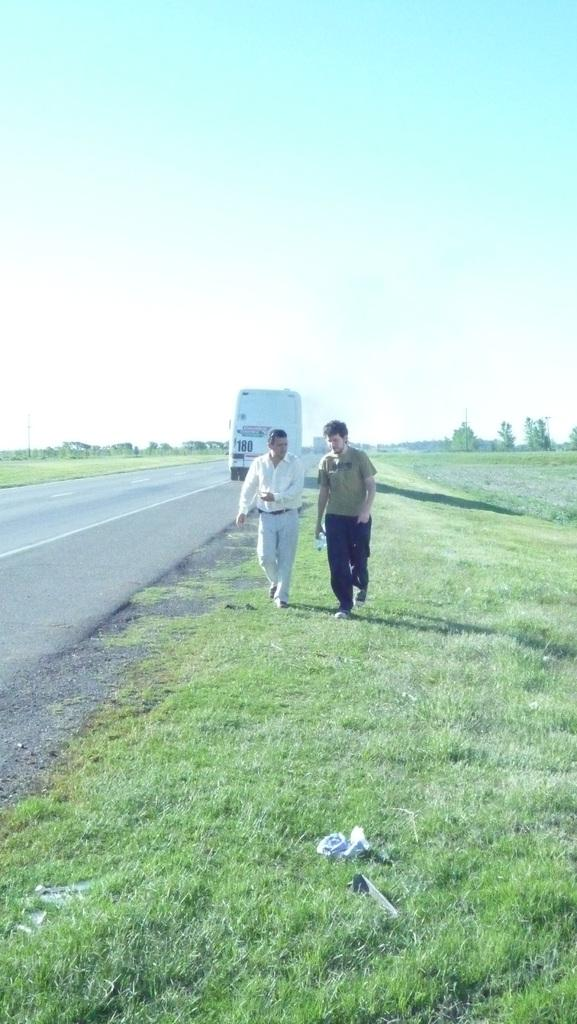What are the persons in the image doing? The persons in the image are walking on the grass in the center of the image. What can be seen in the background of the image? In the background, there is a road, vehicles, grass, trees, and the sky. Can you describe the ground in the image? There is grass at the bottom of the image. How does the doll contribute to the pollution in the image? There is no doll present in the image, so it cannot contribute to any pollution. 